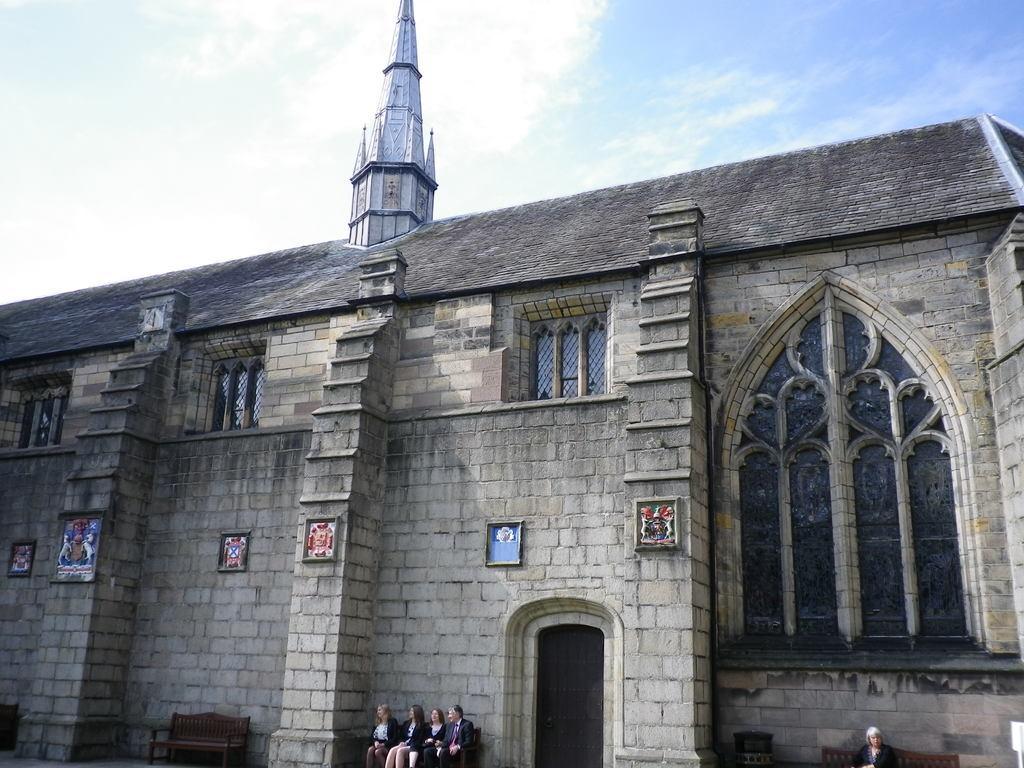How would you summarize this image in a sentence or two? In this image I can see few benches and few persons sitting on the benches. I can see a building which is cream and black in color. I can see few photo frames attached to the building and few windows of the building. In the background I can see the sky. 